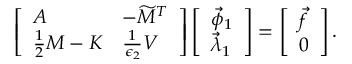<formula> <loc_0><loc_0><loc_500><loc_500>\begin{array} { r } { \left [ \begin{array} { l l } { A } & { - \widetilde { M } ^ { T } } \\ { \frac { 1 } { 2 } M - K } & { \frac { 1 } { \epsilon _ { 2 } } V } \end{array} \right ] \left [ \begin{array} { l } { \vec { \phi } _ { 1 } } \\ { \vec { \lambda } _ { 1 } } \end{array} \right ] = \left [ \begin{array} { l } { \vec { f } } \\ { 0 } \end{array} \right ] . } \end{array}</formula> 